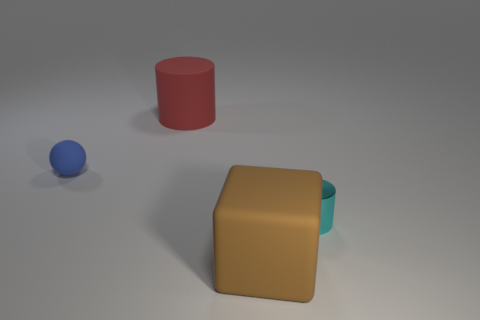Add 3 brown blocks. How many objects exist? 7 Subtract all cubes. How many objects are left? 3 Subtract all big red rubber objects. Subtract all big brown cubes. How many objects are left? 2 Add 1 small balls. How many small balls are left? 2 Add 1 small blue cylinders. How many small blue cylinders exist? 1 Subtract 0 blue blocks. How many objects are left? 4 